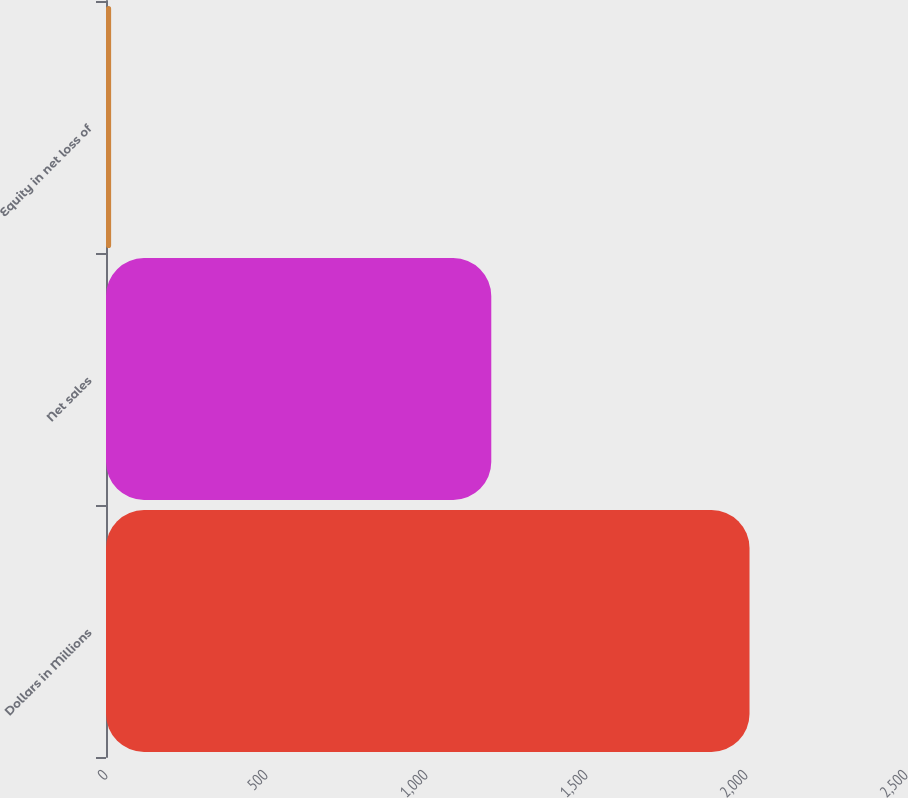Convert chart to OTSL. <chart><loc_0><loc_0><loc_500><loc_500><bar_chart><fcel>Dollars in Millions<fcel>Net sales<fcel>Equity in net loss of<nl><fcel>2011<fcel>1204<fcel>16<nl></chart> 